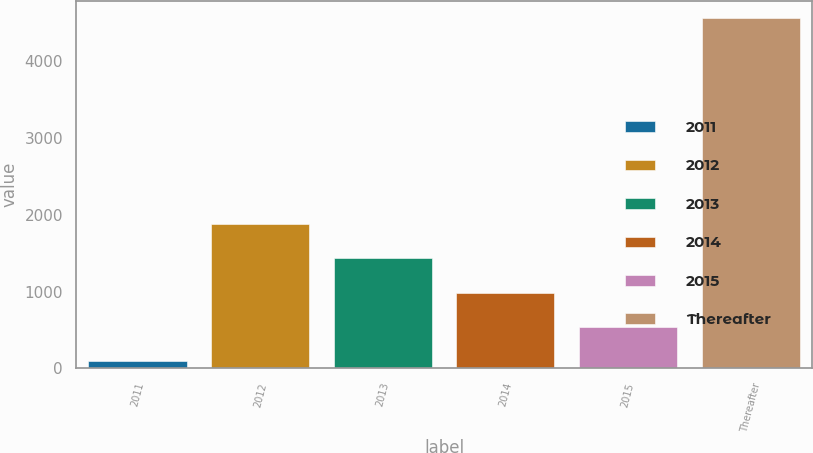<chart> <loc_0><loc_0><loc_500><loc_500><bar_chart><fcel>2011<fcel>2012<fcel>2013<fcel>2014<fcel>2015<fcel>Thereafter<nl><fcel>93.9<fcel>1880.3<fcel>1433.7<fcel>987.1<fcel>540.5<fcel>4559.9<nl></chart> 